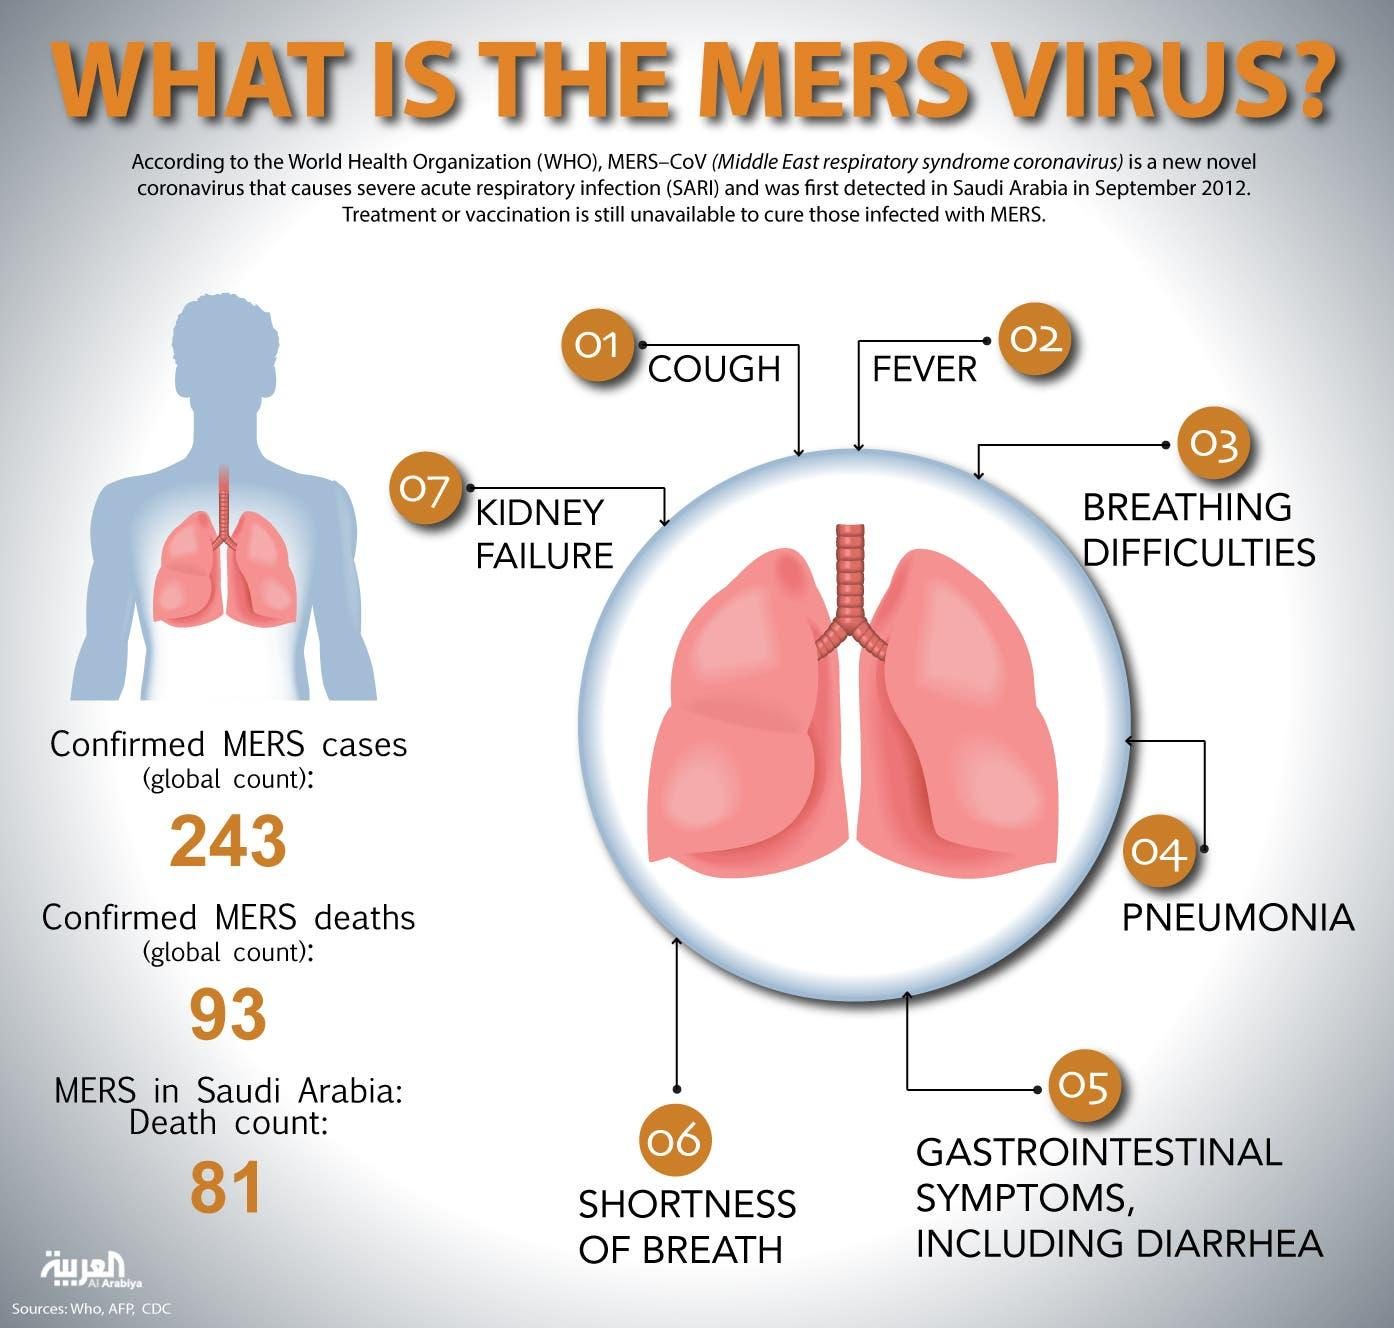Highlight a few significant elements in this photo. There is a difference between confirmed cases of Middle East Respiratory Syndrome (MERS) and deaths caused by the disease. Specifically, there are 150 confirmed cases of MERS and 48 deaths caused by the disease. The number of symptoms associated with the MERS virus is reported to be 7. There have been 81 reported deaths in Saudi Arabia. 